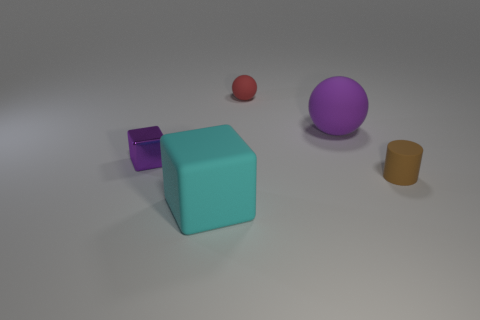Add 4 tiny brown matte cylinders. How many objects exist? 9 Subtract all cyan blocks. How many blocks are left? 1 Subtract all blocks. How many objects are left? 3 Subtract all brown blocks. Subtract all gray cylinders. How many blocks are left? 2 Subtract all gray cylinders. How many gray cubes are left? 0 Subtract all big rubber cylinders. Subtract all purple matte things. How many objects are left? 4 Add 4 brown cylinders. How many brown cylinders are left? 5 Add 5 small brown things. How many small brown things exist? 6 Subtract 0 brown balls. How many objects are left? 5 Subtract 1 cylinders. How many cylinders are left? 0 